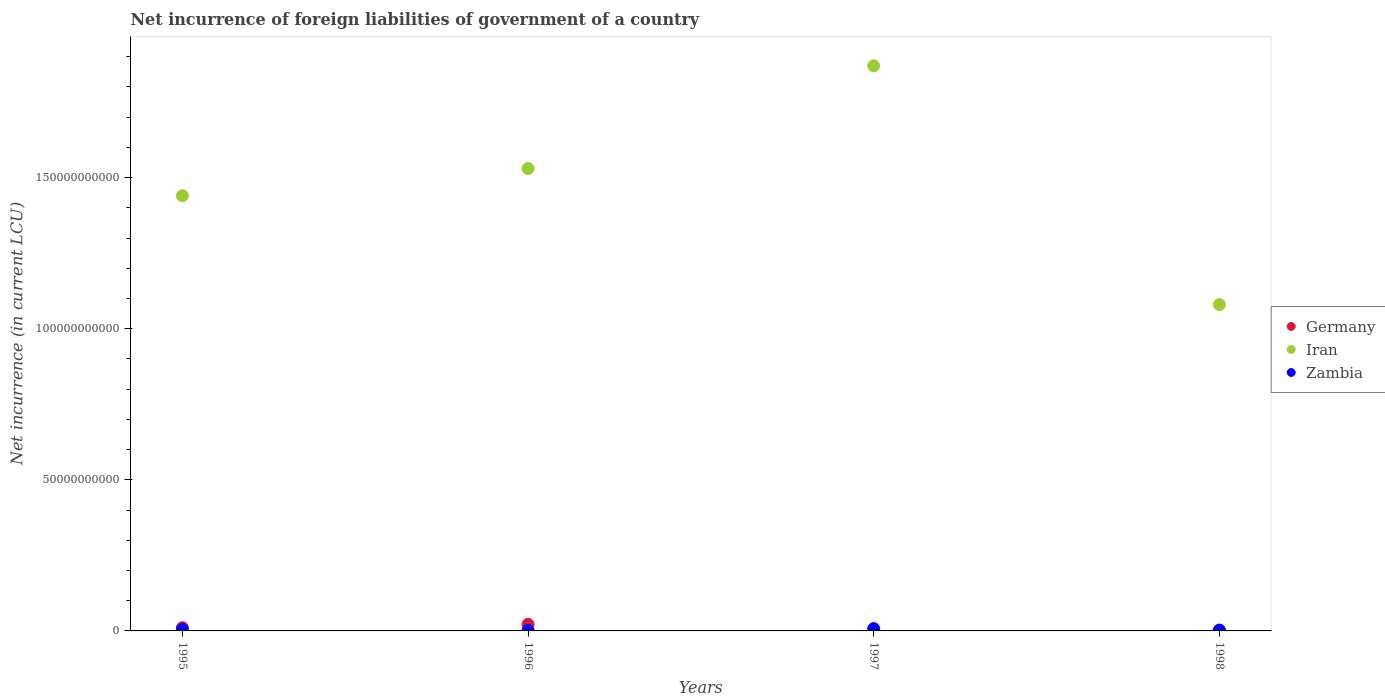How many different coloured dotlines are there?
Provide a short and direct response. 3. Across all years, what is the maximum net incurrence of foreign liabilities in Iran?
Your answer should be very brief. 1.87e+11. Across all years, what is the minimum net incurrence of foreign liabilities in Zambia?
Ensure brevity in your answer.  1.87e+08. What is the total net incurrence of foreign liabilities in Germany in the graph?
Your answer should be very brief. 3.31e+09. What is the difference between the net incurrence of foreign liabilities in Germany in 1995 and that in 1998?
Your answer should be compact. 1.05e+09. What is the difference between the net incurrence of foreign liabilities in Zambia in 1995 and the net incurrence of foreign liabilities in Iran in 1996?
Provide a succinct answer. -1.53e+11. What is the average net incurrence of foreign liabilities in Iran per year?
Your answer should be very brief. 1.48e+11. In the year 1996, what is the difference between the net incurrence of foreign liabilities in Iran and net incurrence of foreign liabilities in Zambia?
Your response must be concise. 1.53e+11. What is the ratio of the net incurrence of foreign liabilities in Zambia in 1996 to that in 1997?
Your answer should be very brief. 0.24. Is the net incurrence of foreign liabilities in Zambia in 1995 less than that in 1996?
Give a very brief answer. No. Is the difference between the net incurrence of foreign liabilities in Iran in 1995 and 1998 greater than the difference between the net incurrence of foreign liabilities in Zambia in 1995 and 1998?
Offer a terse response. Yes. What is the difference between the highest and the second highest net incurrence of foreign liabilities in Iran?
Keep it short and to the point. 3.40e+1. What is the difference between the highest and the lowest net incurrence of foreign liabilities in Germany?
Your response must be concise. 2.20e+09. Does the net incurrence of foreign liabilities in Zambia monotonically increase over the years?
Your answer should be very brief. No. Is the net incurrence of foreign liabilities in Germany strictly less than the net incurrence of foreign liabilities in Iran over the years?
Your response must be concise. Yes. Does the graph contain any zero values?
Offer a terse response. Yes. Where does the legend appear in the graph?
Your answer should be very brief. Center right. How many legend labels are there?
Ensure brevity in your answer.  3. What is the title of the graph?
Offer a very short reply. Net incurrence of foreign liabilities of government of a country. Does "Estonia" appear as one of the legend labels in the graph?
Provide a short and direct response. No. What is the label or title of the X-axis?
Provide a succinct answer. Years. What is the label or title of the Y-axis?
Your response must be concise. Net incurrence (in current LCU). What is the Net incurrence (in current LCU) in Germany in 1995?
Keep it short and to the point. 1.08e+09. What is the Net incurrence (in current LCU) of Iran in 1995?
Make the answer very short. 1.44e+11. What is the Net incurrence (in current LCU) of Zambia in 1995?
Your response must be concise. 4.88e+08. What is the Net incurrence (in current LCU) in Germany in 1996?
Provide a succinct answer. 2.20e+09. What is the Net incurrence (in current LCU) in Iran in 1996?
Your answer should be very brief. 1.53e+11. What is the Net incurrence (in current LCU) of Zambia in 1996?
Ensure brevity in your answer.  1.87e+08. What is the Net incurrence (in current LCU) of Germany in 1997?
Your answer should be compact. 0. What is the Net incurrence (in current LCU) of Iran in 1997?
Make the answer very short. 1.87e+11. What is the Net incurrence (in current LCU) in Zambia in 1997?
Keep it short and to the point. 7.72e+08. What is the Net incurrence (in current LCU) of Germany in 1998?
Your response must be concise. 2.80e+07. What is the Net incurrence (in current LCU) in Iran in 1998?
Your answer should be very brief. 1.08e+11. What is the Net incurrence (in current LCU) in Zambia in 1998?
Ensure brevity in your answer.  2.80e+08. Across all years, what is the maximum Net incurrence (in current LCU) of Germany?
Offer a terse response. 2.20e+09. Across all years, what is the maximum Net incurrence (in current LCU) in Iran?
Make the answer very short. 1.87e+11. Across all years, what is the maximum Net incurrence (in current LCU) of Zambia?
Provide a short and direct response. 7.72e+08. Across all years, what is the minimum Net incurrence (in current LCU) in Germany?
Provide a succinct answer. 0. Across all years, what is the minimum Net incurrence (in current LCU) in Iran?
Provide a short and direct response. 1.08e+11. Across all years, what is the minimum Net incurrence (in current LCU) in Zambia?
Provide a succinct answer. 1.87e+08. What is the total Net incurrence (in current LCU) of Germany in the graph?
Your response must be concise. 3.31e+09. What is the total Net incurrence (in current LCU) in Iran in the graph?
Offer a very short reply. 5.92e+11. What is the total Net incurrence (in current LCU) of Zambia in the graph?
Make the answer very short. 1.73e+09. What is the difference between the Net incurrence (in current LCU) in Germany in 1995 and that in 1996?
Provide a succinct answer. -1.13e+09. What is the difference between the Net incurrence (in current LCU) of Iran in 1995 and that in 1996?
Your answer should be compact. -9.00e+09. What is the difference between the Net incurrence (in current LCU) in Zambia in 1995 and that in 1996?
Offer a terse response. 3.01e+08. What is the difference between the Net incurrence (in current LCU) of Iran in 1995 and that in 1997?
Give a very brief answer. -4.30e+1. What is the difference between the Net incurrence (in current LCU) of Zambia in 1995 and that in 1997?
Ensure brevity in your answer.  -2.84e+08. What is the difference between the Net incurrence (in current LCU) in Germany in 1995 and that in 1998?
Offer a terse response. 1.05e+09. What is the difference between the Net incurrence (in current LCU) of Iran in 1995 and that in 1998?
Give a very brief answer. 3.60e+1. What is the difference between the Net incurrence (in current LCU) in Zambia in 1995 and that in 1998?
Keep it short and to the point. 2.08e+08. What is the difference between the Net incurrence (in current LCU) in Iran in 1996 and that in 1997?
Offer a terse response. -3.40e+1. What is the difference between the Net incurrence (in current LCU) of Zambia in 1996 and that in 1997?
Keep it short and to the point. -5.85e+08. What is the difference between the Net incurrence (in current LCU) of Germany in 1996 and that in 1998?
Your answer should be compact. 2.18e+09. What is the difference between the Net incurrence (in current LCU) in Iran in 1996 and that in 1998?
Give a very brief answer. 4.50e+1. What is the difference between the Net incurrence (in current LCU) of Zambia in 1996 and that in 1998?
Provide a short and direct response. -9.28e+07. What is the difference between the Net incurrence (in current LCU) in Iran in 1997 and that in 1998?
Your answer should be compact. 7.90e+1. What is the difference between the Net incurrence (in current LCU) of Zambia in 1997 and that in 1998?
Your answer should be very brief. 4.92e+08. What is the difference between the Net incurrence (in current LCU) of Germany in 1995 and the Net incurrence (in current LCU) of Iran in 1996?
Your response must be concise. -1.52e+11. What is the difference between the Net incurrence (in current LCU) of Germany in 1995 and the Net incurrence (in current LCU) of Zambia in 1996?
Your answer should be very brief. 8.92e+08. What is the difference between the Net incurrence (in current LCU) in Iran in 1995 and the Net incurrence (in current LCU) in Zambia in 1996?
Provide a short and direct response. 1.44e+11. What is the difference between the Net incurrence (in current LCU) of Germany in 1995 and the Net incurrence (in current LCU) of Iran in 1997?
Provide a short and direct response. -1.86e+11. What is the difference between the Net incurrence (in current LCU) of Germany in 1995 and the Net incurrence (in current LCU) of Zambia in 1997?
Keep it short and to the point. 3.07e+08. What is the difference between the Net incurrence (in current LCU) in Iran in 1995 and the Net incurrence (in current LCU) in Zambia in 1997?
Your response must be concise. 1.43e+11. What is the difference between the Net incurrence (in current LCU) of Germany in 1995 and the Net incurrence (in current LCU) of Iran in 1998?
Your response must be concise. -1.07e+11. What is the difference between the Net incurrence (in current LCU) in Germany in 1995 and the Net incurrence (in current LCU) in Zambia in 1998?
Offer a very short reply. 7.99e+08. What is the difference between the Net incurrence (in current LCU) of Iran in 1995 and the Net incurrence (in current LCU) of Zambia in 1998?
Your answer should be very brief. 1.44e+11. What is the difference between the Net incurrence (in current LCU) in Germany in 1996 and the Net incurrence (in current LCU) in Iran in 1997?
Give a very brief answer. -1.85e+11. What is the difference between the Net incurrence (in current LCU) of Germany in 1996 and the Net incurrence (in current LCU) of Zambia in 1997?
Your response must be concise. 1.43e+09. What is the difference between the Net incurrence (in current LCU) in Iran in 1996 and the Net incurrence (in current LCU) in Zambia in 1997?
Your answer should be compact. 1.52e+11. What is the difference between the Net incurrence (in current LCU) in Germany in 1996 and the Net incurrence (in current LCU) in Iran in 1998?
Keep it short and to the point. -1.06e+11. What is the difference between the Net incurrence (in current LCU) of Germany in 1996 and the Net incurrence (in current LCU) of Zambia in 1998?
Provide a short and direct response. 1.92e+09. What is the difference between the Net incurrence (in current LCU) of Iran in 1996 and the Net incurrence (in current LCU) of Zambia in 1998?
Offer a terse response. 1.53e+11. What is the difference between the Net incurrence (in current LCU) in Iran in 1997 and the Net incurrence (in current LCU) in Zambia in 1998?
Your response must be concise. 1.87e+11. What is the average Net incurrence (in current LCU) in Germany per year?
Your answer should be compact. 8.28e+08. What is the average Net incurrence (in current LCU) in Iran per year?
Your answer should be compact. 1.48e+11. What is the average Net incurrence (in current LCU) in Zambia per year?
Provide a succinct answer. 4.32e+08. In the year 1995, what is the difference between the Net incurrence (in current LCU) in Germany and Net incurrence (in current LCU) in Iran?
Offer a very short reply. -1.43e+11. In the year 1995, what is the difference between the Net incurrence (in current LCU) of Germany and Net incurrence (in current LCU) of Zambia?
Your response must be concise. 5.91e+08. In the year 1995, what is the difference between the Net incurrence (in current LCU) of Iran and Net incurrence (in current LCU) of Zambia?
Give a very brief answer. 1.44e+11. In the year 1996, what is the difference between the Net incurrence (in current LCU) in Germany and Net incurrence (in current LCU) in Iran?
Give a very brief answer. -1.51e+11. In the year 1996, what is the difference between the Net incurrence (in current LCU) of Germany and Net incurrence (in current LCU) of Zambia?
Ensure brevity in your answer.  2.02e+09. In the year 1996, what is the difference between the Net incurrence (in current LCU) in Iran and Net incurrence (in current LCU) in Zambia?
Your answer should be compact. 1.53e+11. In the year 1997, what is the difference between the Net incurrence (in current LCU) in Iran and Net incurrence (in current LCU) in Zambia?
Keep it short and to the point. 1.86e+11. In the year 1998, what is the difference between the Net incurrence (in current LCU) in Germany and Net incurrence (in current LCU) in Iran?
Ensure brevity in your answer.  -1.08e+11. In the year 1998, what is the difference between the Net incurrence (in current LCU) in Germany and Net incurrence (in current LCU) in Zambia?
Provide a succinct answer. -2.52e+08. In the year 1998, what is the difference between the Net incurrence (in current LCU) in Iran and Net incurrence (in current LCU) in Zambia?
Make the answer very short. 1.08e+11. What is the ratio of the Net incurrence (in current LCU) of Germany in 1995 to that in 1996?
Ensure brevity in your answer.  0.49. What is the ratio of the Net incurrence (in current LCU) of Iran in 1995 to that in 1996?
Your answer should be compact. 0.94. What is the ratio of the Net incurrence (in current LCU) of Zambia in 1995 to that in 1996?
Offer a very short reply. 2.61. What is the ratio of the Net incurrence (in current LCU) of Iran in 1995 to that in 1997?
Make the answer very short. 0.77. What is the ratio of the Net incurrence (in current LCU) of Zambia in 1995 to that in 1997?
Make the answer very short. 0.63. What is the ratio of the Net incurrence (in current LCU) of Germany in 1995 to that in 1998?
Offer a very short reply. 38.54. What is the ratio of the Net incurrence (in current LCU) of Iran in 1995 to that in 1998?
Your response must be concise. 1.33. What is the ratio of the Net incurrence (in current LCU) of Zambia in 1995 to that in 1998?
Provide a short and direct response. 1.74. What is the ratio of the Net incurrence (in current LCU) of Iran in 1996 to that in 1997?
Provide a short and direct response. 0.82. What is the ratio of the Net incurrence (in current LCU) in Zambia in 1996 to that in 1997?
Provide a succinct answer. 0.24. What is the ratio of the Net incurrence (in current LCU) in Germany in 1996 to that in 1998?
Your answer should be compact. 78.75. What is the ratio of the Net incurrence (in current LCU) of Iran in 1996 to that in 1998?
Offer a terse response. 1.42. What is the ratio of the Net incurrence (in current LCU) in Zambia in 1996 to that in 1998?
Keep it short and to the point. 0.67. What is the ratio of the Net incurrence (in current LCU) of Iran in 1997 to that in 1998?
Keep it short and to the point. 1.73. What is the ratio of the Net incurrence (in current LCU) of Zambia in 1997 to that in 1998?
Give a very brief answer. 2.76. What is the difference between the highest and the second highest Net incurrence (in current LCU) of Germany?
Offer a very short reply. 1.13e+09. What is the difference between the highest and the second highest Net incurrence (in current LCU) in Iran?
Provide a short and direct response. 3.40e+1. What is the difference between the highest and the second highest Net incurrence (in current LCU) of Zambia?
Offer a very short reply. 2.84e+08. What is the difference between the highest and the lowest Net incurrence (in current LCU) of Germany?
Make the answer very short. 2.20e+09. What is the difference between the highest and the lowest Net incurrence (in current LCU) of Iran?
Provide a short and direct response. 7.90e+1. What is the difference between the highest and the lowest Net incurrence (in current LCU) in Zambia?
Your answer should be compact. 5.85e+08. 